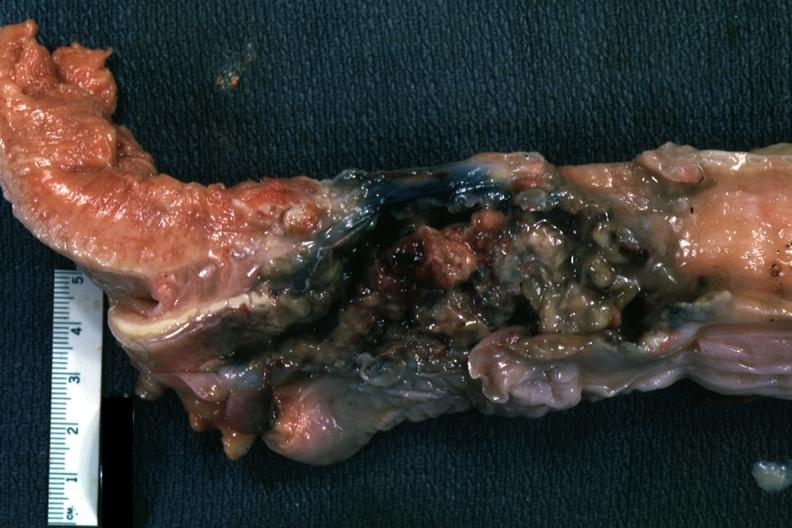does this image show larynx is mass of necrotic tissue?
Answer the question using a single word or phrase. Yes 